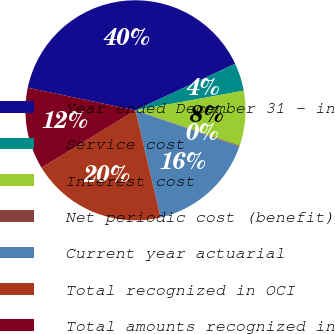<chart> <loc_0><loc_0><loc_500><loc_500><pie_chart><fcel>Year ended December 31 - in<fcel>Service cost<fcel>Interest cost<fcel>Net periodic cost (benefit)<fcel>Current year actuarial<fcel>Total recognized in OCI<fcel>Total amounts recognized in<nl><fcel>39.75%<fcel>4.1%<fcel>8.06%<fcel>0.14%<fcel>15.98%<fcel>19.94%<fcel>12.02%<nl></chart> 